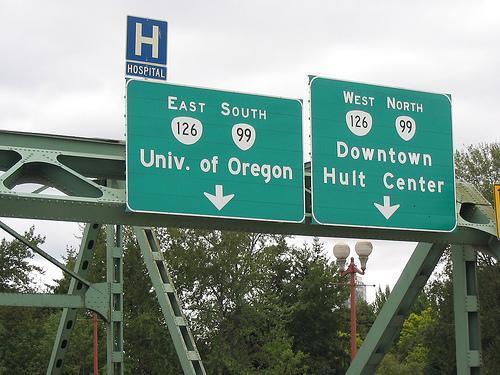How many green signs are in the picture?
Give a very brief answer. 2. 